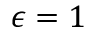Convert formula to latex. <formula><loc_0><loc_0><loc_500><loc_500>\epsilon = 1</formula> 